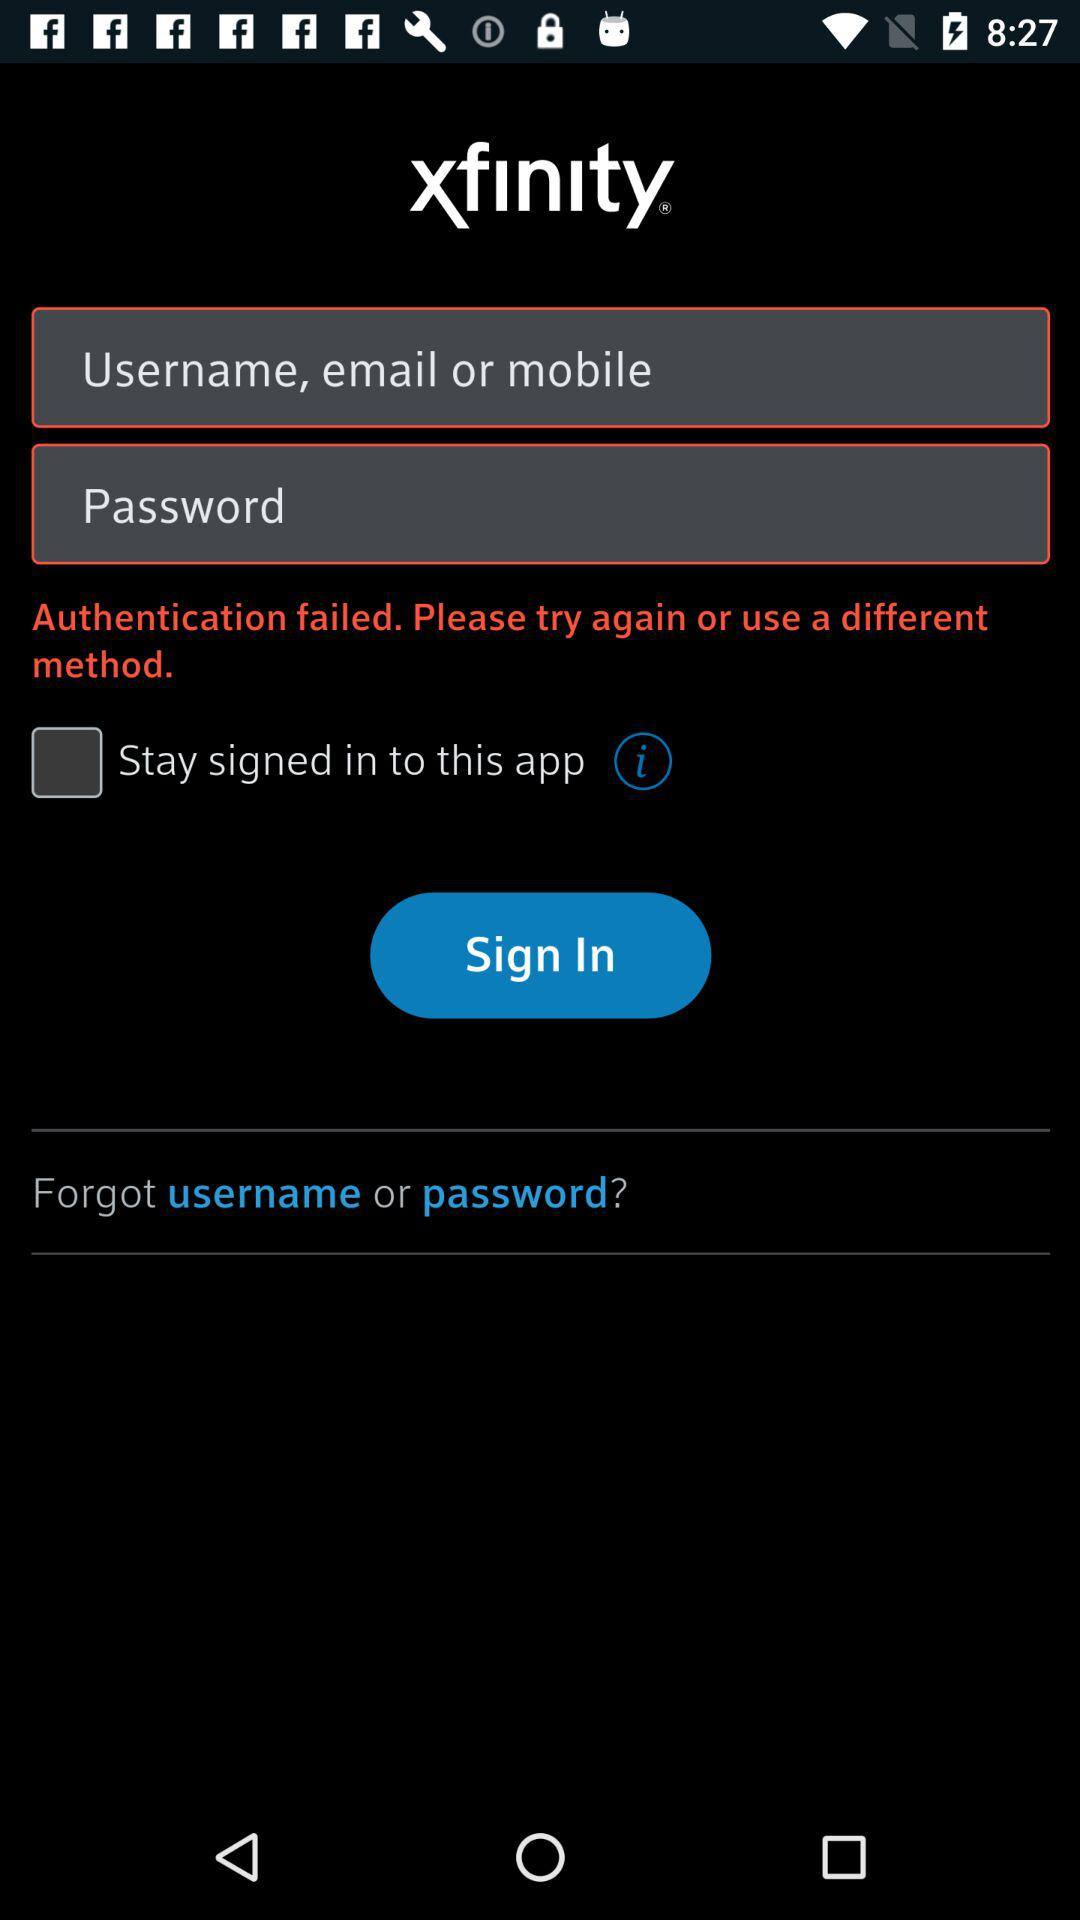Can we reset password?
When the provided information is insufficient, respond with <no answer>. <no answer> 